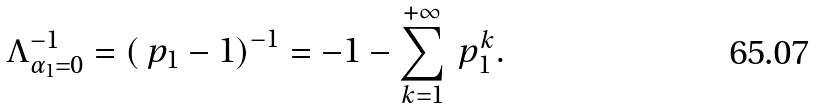<formula> <loc_0><loc_0><loc_500><loc_500>\Lambda _ { \alpha _ { 1 } = 0 } ^ { - 1 } = \left ( \ p _ { 1 } - 1 \right ) ^ { - 1 } = - 1 - \sum _ { k = 1 } ^ { + \infty } \ p _ { 1 } ^ { k } .</formula> 